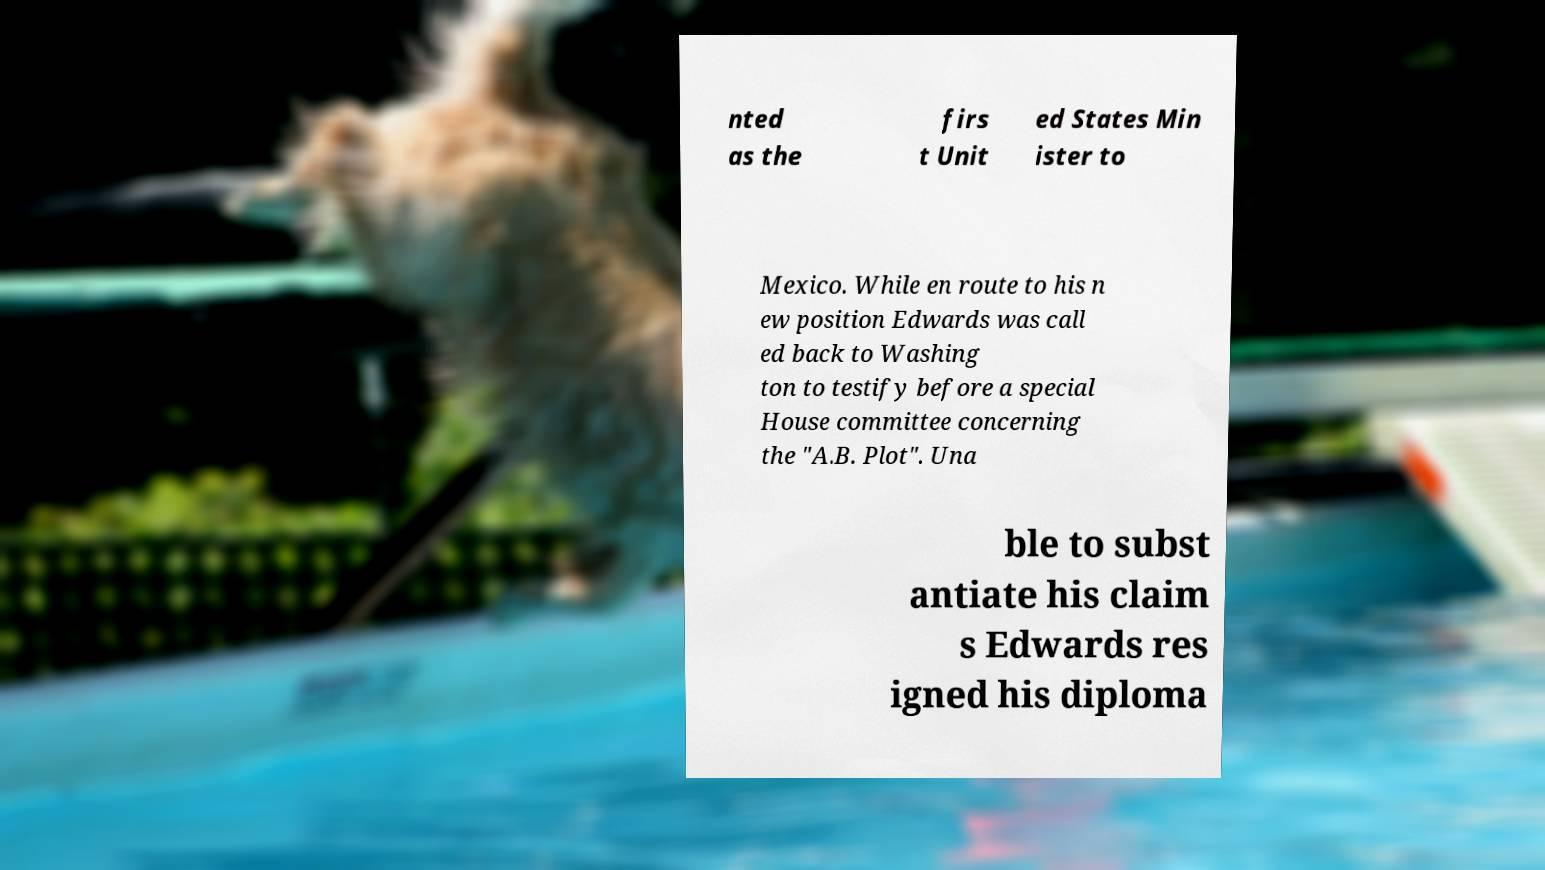I need the written content from this picture converted into text. Can you do that? nted as the firs t Unit ed States Min ister to Mexico. While en route to his n ew position Edwards was call ed back to Washing ton to testify before a special House committee concerning the "A.B. Plot". Una ble to subst antiate his claim s Edwards res igned his diploma 